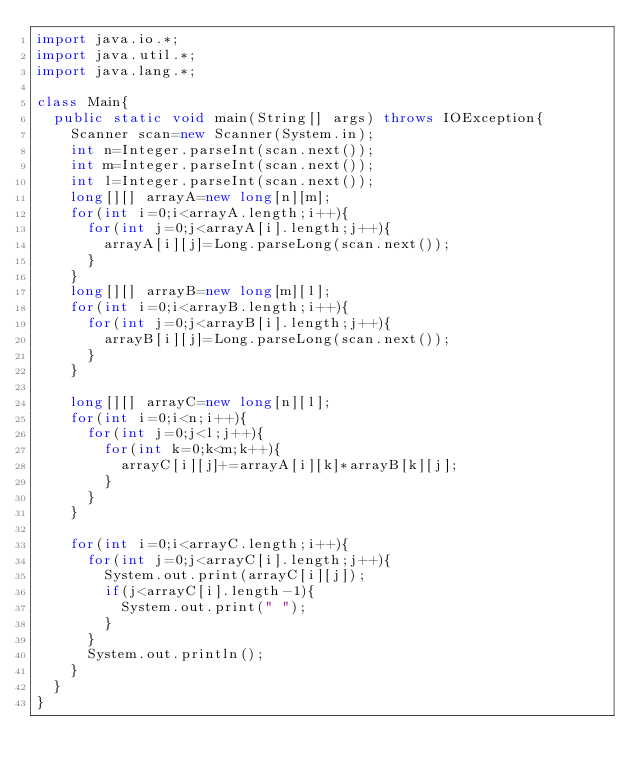Convert code to text. <code><loc_0><loc_0><loc_500><loc_500><_Java_>import java.io.*;
import java.util.*;
import java.lang.*;

class Main{
  public static void main(String[] args) throws IOException{
    Scanner scan=new Scanner(System.in);
    int n=Integer.parseInt(scan.next());
    int m=Integer.parseInt(scan.next());
    int l=Integer.parseInt(scan.next());
    long[][] arrayA=new long[n][m];
    for(int i=0;i<arrayA.length;i++){
      for(int j=0;j<arrayA[i].length;j++){
        arrayA[i][j]=Long.parseLong(scan.next());
      }
    }
    long[][] arrayB=new long[m][l];
    for(int i=0;i<arrayB.length;i++){
      for(int j=0;j<arrayB[i].length;j++){
        arrayB[i][j]=Long.parseLong(scan.next());
      }
    }

    long[][] arrayC=new long[n][l];
    for(int i=0;i<n;i++){
      for(int j=0;j<l;j++){
        for(int k=0;k<m;k++){
          arrayC[i][j]+=arrayA[i][k]*arrayB[k][j];
        }
      }
    }

    for(int i=0;i<arrayC.length;i++){
      for(int j=0;j<arrayC[i].length;j++){
        System.out.print(arrayC[i][j]);
        if(j<arrayC[i].length-1){
          System.out.print(" ");
        }
      }
      System.out.println();
    }
  }
}
</code> 